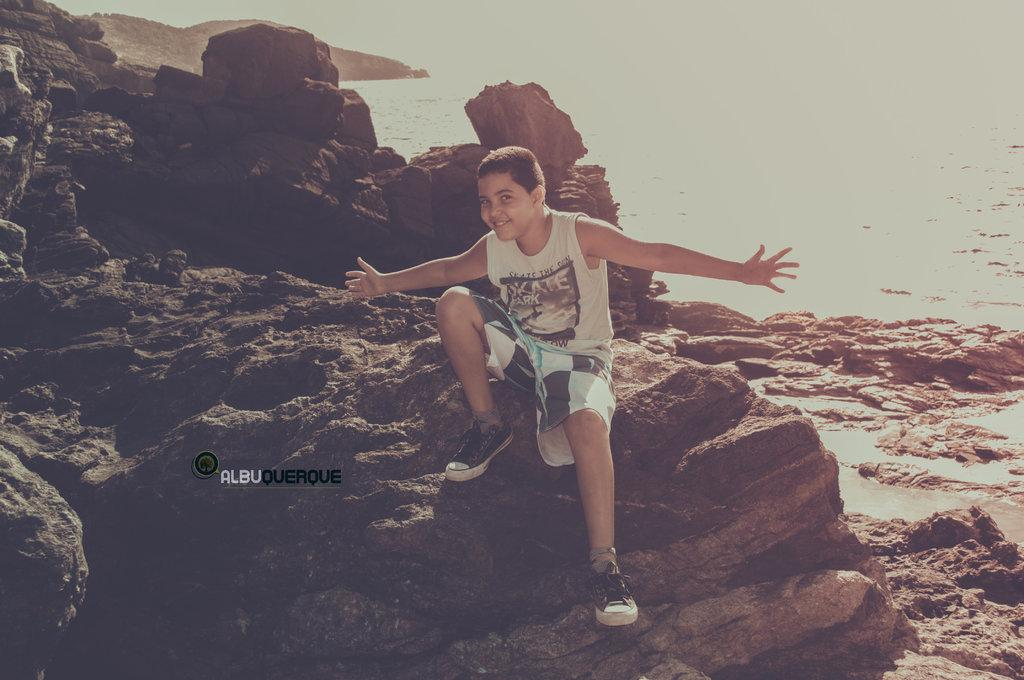Who is the main subject in the image? There is a boy in the image. What is the boy doing in the image? The boy is sitting on a rock. What can be seen in the background of the image? There is water visible in the background of the image. What type of coat is the boy wearing in the image? There is no coat visible in the image; the boy is not wearing one. What kind of flower can be seen growing near the rock? There are no flowers present in the image; only the boy, the rock, and the water are visible. 